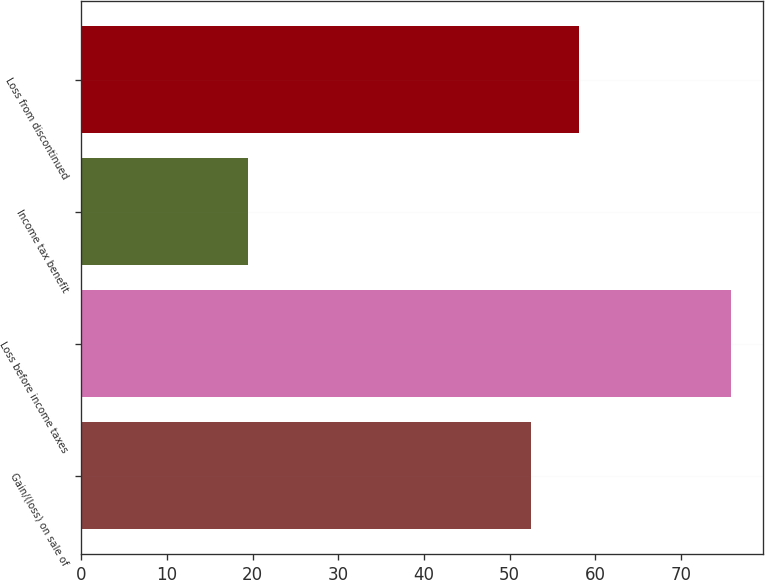Convert chart. <chart><loc_0><loc_0><loc_500><loc_500><bar_chart><fcel>Gain/(loss) on sale of<fcel>Loss before income taxes<fcel>Income tax benefit<fcel>Loss from discontinued<nl><fcel>52.5<fcel>75.8<fcel>19.4<fcel>58.14<nl></chart> 